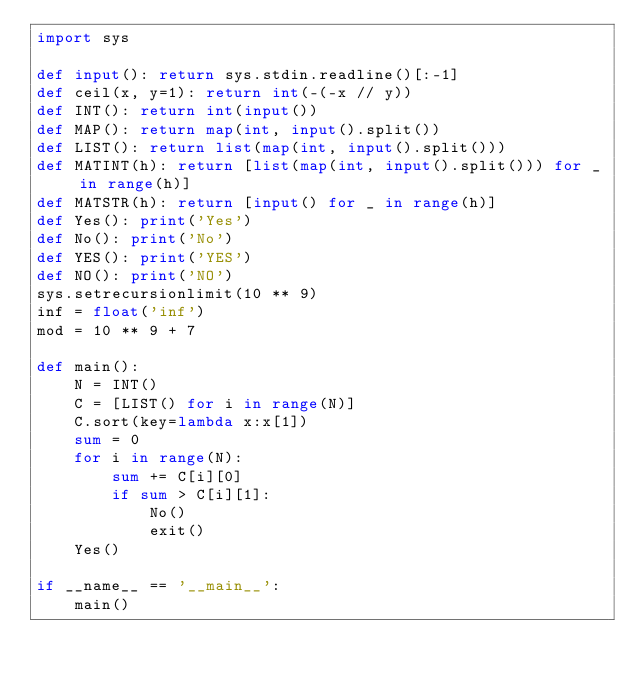<code> <loc_0><loc_0><loc_500><loc_500><_Python_>import sys

def input(): return sys.stdin.readline()[:-1]
def ceil(x, y=1): return int(-(-x // y))
def INT(): return int(input())
def MAP(): return map(int, input().split())
def LIST(): return list(map(int, input().split()))
def MATINT(h): return [list(map(int, input().split())) for _ in range(h)]
def MATSTR(h): return [input() for _ in range(h)]
def Yes(): print('Yes')
def No(): print('No')
def YES(): print('YES')
def NO(): print('NO')
sys.setrecursionlimit(10 ** 9)
inf = float('inf')
mod = 10 ** 9 + 7

def main():
    N = INT()
    C = [LIST() for i in range(N)]
    C.sort(key=lambda x:x[1])
    sum = 0
    for i in range(N):
        sum += C[i][0]
        if sum > C[i][1]:
            No()
            exit()
    Yes()

if __name__ == '__main__':
    main()
</code> 